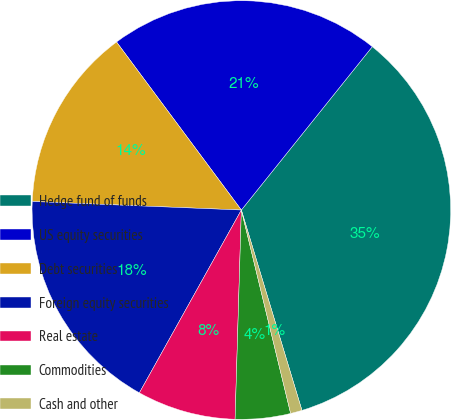Convert chart to OTSL. <chart><loc_0><loc_0><loc_500><loc_500><pie_chart><fcel>Hedge fund of funds<fcel>US equity securities<fcel>Debt securities<fcel>Foreign equity securities<fcel>Real estate<fcel>Commodities<fcel>Cash and other<nl><fcel>34.57%<fcel>20.92%<fcel>14.18%<fcel>17.55%<fcel>7.62%<fcel>4.26%<fcel>0.89%<nl></chart> 